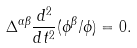Convert formula to latex. <formula><loc_0><loc_0><loc_500><loc_500>\Delta ^ { \alpha \beta } \frac { d ^ { 2 } } { d t ^ { 2 } } ( \phi ^ { \beta } / { \phi } ) = 0 .</formula> 